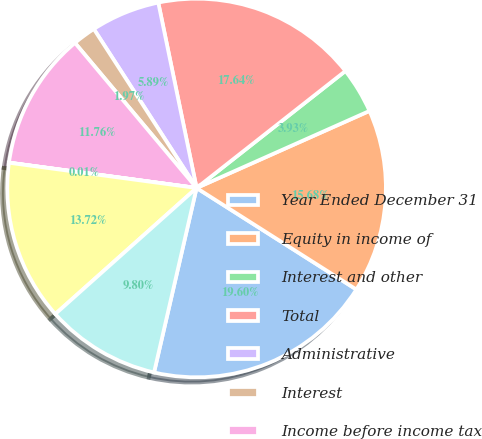<chart> <loc_0><loc_0><loc_500><loc_500><pie_chart><fcel>Year Ended December 31<fcel>Equity in income of<fcel>Interest and other<fcel>Total<fcel>Administrative<fcel>Interest<fcel>Income before income tax<fcel>Income tax benefit<fcel>Net income<fcel>Equity in other comprehensive<nl><fcel>19.6%<fcel>15.68%<fcel>3.93%<fcel>17.64%<fcel>5.89%<fcel>1.97%<fcel>11.76%<fcel>0.01%<fcel>13.72%<fcel>9.8%<nl></chart> 